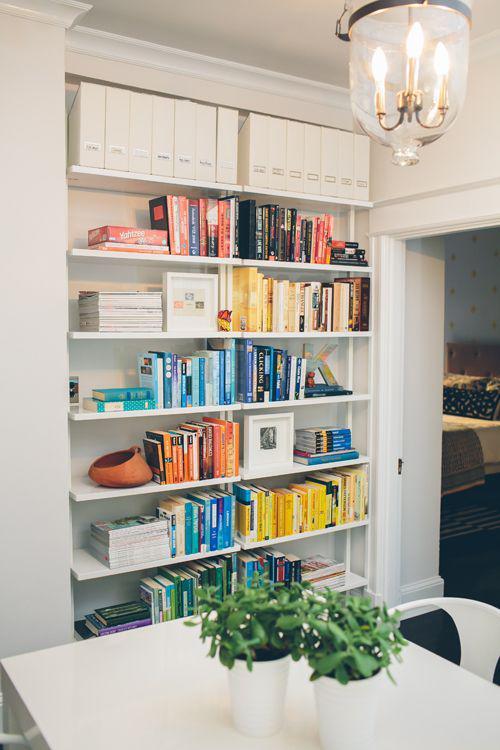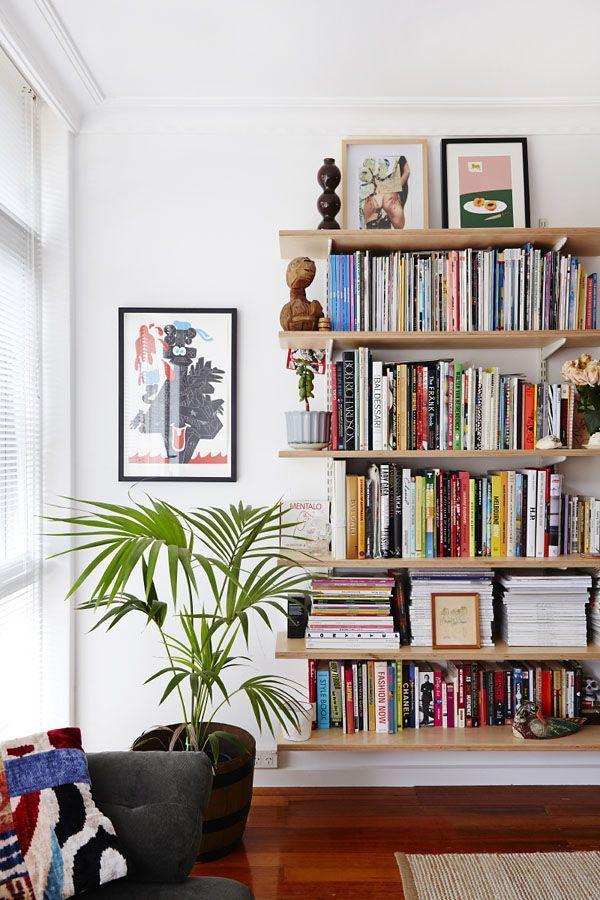The first image is the image on the left, the second image is the image on the right. Given the left and right images, does the statement "Left image shows traditional built-in white bookcase with a white back." hold true? Answer yes or no. Yes. The first image is the image on the left, the second image is the image on the right. Given the left and right images, does the statement "The bookshelves in at least one image are flat boards with at least one open end, with items on the shelves serving as bookends." hold true? Answer yes or no. Yes. 